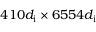<formula> <loc_0><loc_0><loc_500><loc_500>4 1 0 d _ { i } \times 6 5 5 4 d _ { i }</formula> 